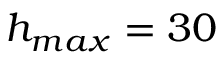<formula> <loc_0><loc_0><loc_500><loc_500>h _ { \max } = 3 0</formula> 